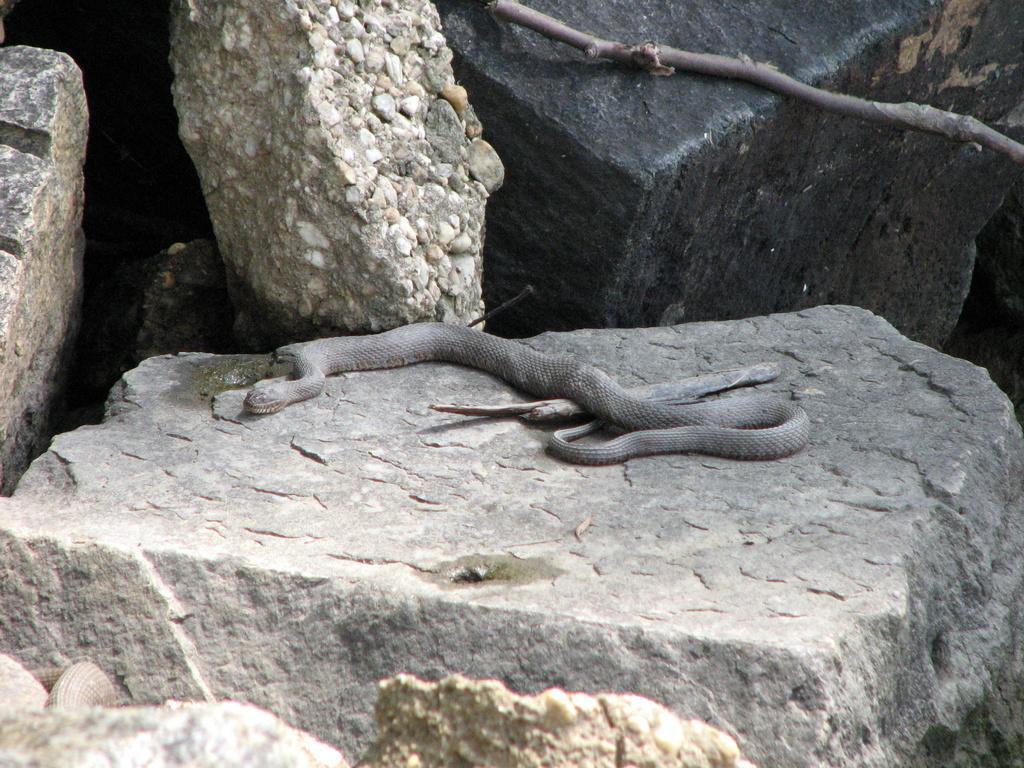How would you summarize this image in a sentence or two? In this image at front there are rocks and at the center of the rock there is a snake. Beside the snake there is a wooden stick. 